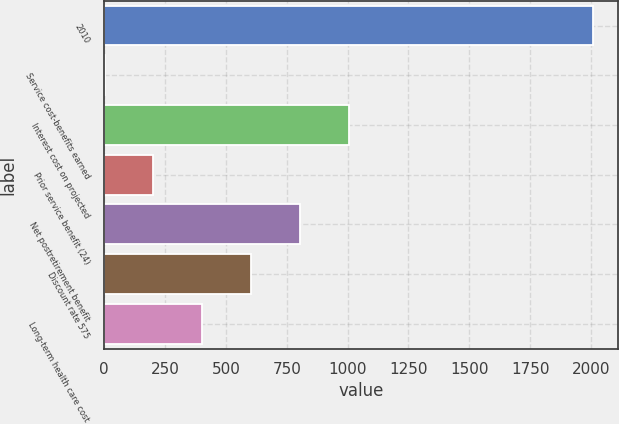<chart> <loc_0><loc_0><loc_500><loc_500><bar_chart><fcel>2010<fcel>Service cost-benefits earned<fcel>Interest cost on projected<fcel>Prior service benefit (24)<fcel>Net postretirement benefit<fcel>Discount rate 575<fcel>Long-term health care cost<nl><fcel>2009<fcel>1.5<fcel>1005.25<fcel>202.25<fcel>804.5<fcel>603.75<fcel>403<nl></chart> 